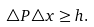<formula> <loc_0><loc_0><loc_500><loc_500>\triangle { P } \triangle { x } \geq h .</formula> 